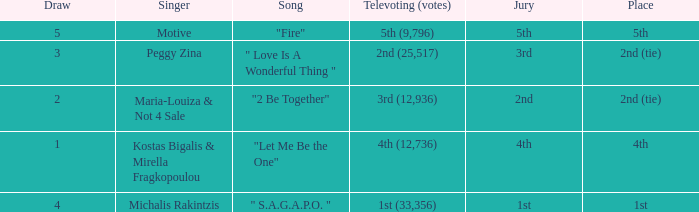What song was 2nd (25,517) in televoting (votes)? " Love Is A Wonderful Thing ". 